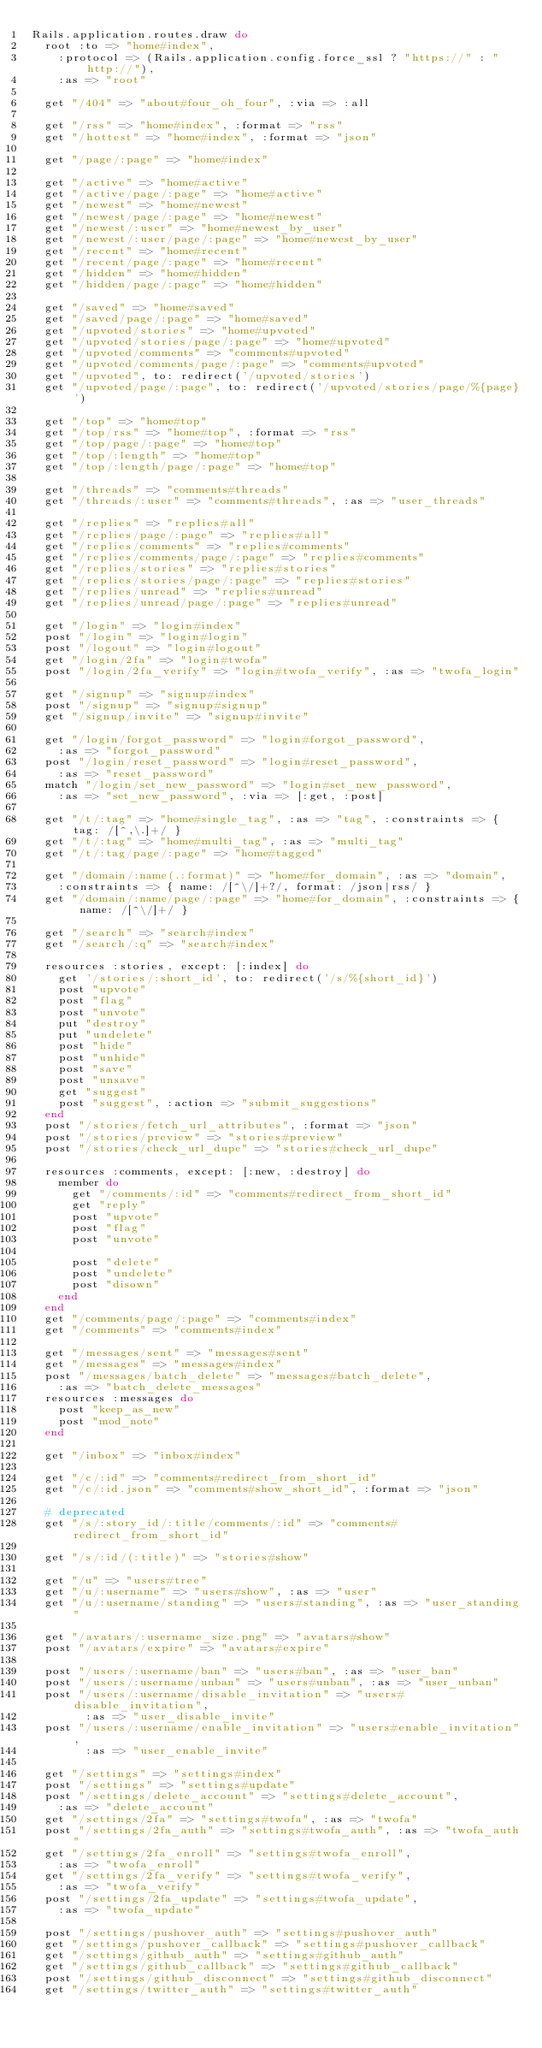<code> <loc_0><loc_0><loc_500><loc_500><_Ruby_>Rails.application.routes.draw do
  root :to => "home#index",
    :protocol => (Rails.application.config.force_ssl ? "https://" : "http://"),
    :as => "root"

  get "/404" => "about#four_oh_four", :via => :all

  get "/rss" => "home#index", :format => "rss"
  get "/hottest" => "home#index", :format => "json"

  get "/page/:page" => "home#index"

  get "/active" => "home#active"
  get "/active/page/:page" => "home#active"
  get "/newest" => "home#newest"
  get "/newest/page/:page" => "home#newest"
  get "/newest/:user" => "home#newest_by_user"
  get "/newest/:user/page/:page" => "home#newest_by_user"
  get "/recent" => "home#recent"
  get "/recent/page/:page" => "home#recent"
  get "/hidden" => "home#hidden"
  get "/hidden/page/:page" => "home#hidden"

  get "/saved" => "home#saved"
  get "/saved/page/:page" => "home#saved"
  get "/upvoted/stories" => "home#upvoted"
  get "/upvoted/stories/page/:page" => "home#upvoted"
  get "/upvoted/comments" => "comments#upvoted"
  get "/upvoted/comments/page/:page" => "comments#upvoted"
  get "/upvoted", to: redirect('/upvoted/stories')
  get "/upvoted/page/:page", to: redirect('/upvoted/stories/page/%{page}')

  get "/top" => "home#top"
  get "/top/rss" => "home#top", :format => "rss"
  get "/top/page/:page" => "home#top"
  get "/top/:length" => "home#top"
  get "/top/:length/page/:page" => "home#top"

  get "/threads" => "comments#threads"
  get "/threads/:user" => "comments#threads", :as => "user_threads"

  get "/replies" => "replies#all"
  get "/replies/page/:page" => "replies#all"
  get "/replies/comments" => "replies#comments"
  get "/replies/comments/page/:page" => "replies#comments"
  get "/replies/stories" => "replies#stories"
  get "/replies/stories/page/:page" => "replies#stories"
  get "/replies/unread" => "replies#unread"
  get "/replies/unread/page/:page" => "replies#unread"

  get "/login" => "login#index"
  post "/login" => "login#login"
  post "/logout" => "login#logout"
  get "/login/2fa" => "login#twofa"
  post "/login/2fa_verify" => "login#twofa_verify", :as => "twofa_login"

  get "/signup" => "signup#index"
  post "/signup" => "signup#signup"
  get "/signup/invite" => "signup#invite"

  get "/login/forgot_password" => "login#forgot_password",
    :as => "forgot_password"
  post "/login/reset_password" => "login#reset_password",
    :as => "reset_password"
  match "/login/set_new_password" => "login#set_new_password",
    :as => "set_new_password", :via => [:get, :post]

  get "/t/:tag" => "home#single_tag", :as => "tag", :constraints => { tag: /[^,\.]+/ }
  get "/t/:tag" => "home#multi_tag", :as => "multi_tag"
  get "/t/:tag/page/:page" => "home#tagged"

  get "/domain/:name(.:format)" => "home#for_domain", :as => "domain",
    :constraints => { name: /[^\/]+?/, format: /json|rss/ }
  get "/domain/:name/page/:page" => "home#for_domain", :constraints => { name: /[^\/]+/ }

  get "/search" => "search#index"
  get "/search/:q" => "search#index"

  resources :stories, except: [:index] do
    get '/stories/:short_id', to: redirect('/s/%{short_id}')
    post "upvote"
    post "flag"
    post "unvote"
    put "destroy"
    put "undelete"
    post "hide"
    post "unhide"
    post "save"
    post "unsave"
    get "suggest"
    post "suggest", :action => "submit_suggestions"
  end
  post "/stories/fetch_url_attributes", :format => "json"
  post "/stories/preview" => "stories#preview"
  post "/stories/check_url_dupe" => "stories#check_url_dupe"

  resources :comments, except: [:new, :destroy] do
    member do
      get "/comments/:id" => "comments#redirect_from_short_id"
      get "reply"
      post "upvote"
      post "flag"
      post "unvote"

      post "delete"
      post "undelete"
      post "disown"
    end
  end
  get "/comments/page/:page" => "comments#index"
  get "/comments" => "comments#index"

  get "/messages/sent" => "messages#sent"
  get "/messages" => "messages#index"
  post "/messages/batch_delete" => "messages#batch_delete",
    :as => "batch_delete_messages"
  resources :messages do
    post "keep_as_new"
    post "mod_note"
  end

  get "/inbox" => "inbox#index"

  get "/c/:id" => "comments#redirect_from_short_id"
  get "/c/:id.json" => "comments#show_short_id", :format => "json"

  # deprecated
  get "/s/:story_id/:title/comments/:id" => "comments#redirect_from_short_id"

  get "/s/:id/(:title)" => "stories#show"

  get "/u" => "users#tree"
  get "/u/:username" => "users#show", :as => "user"
  get "/u/:username/standing" => "users#standing", :as => "user_standing"

  get "/avatars/:username_size.png" => "avatars#show"
  post "/avatars/expire" => "avatars#expire"

  post "/users/:username/ban" => "users#ban", :as => "user_ban"
  post "/users/:username/unban" => "users#unban", :as => "user_unban"
  post "/users/:username/disable_invitation" => "users#disable_invitation",
        :as => "user_disable_invite"
  post "/users/:username/enable_invitation" => "users#enable_invitation",
        :as => "user_enable_invite"

  get "/settings" => "settings#index"
  post "/settings" => "settings#update"
  post "/settings/delete_account" => "settings#delete_account",
    :as => "delete_account"
  get "/settings/2fa" => "settings#twofa", :as => "twofa"
  post "/settings/2fa_auth" => "settings#twofa_auth", :as => "twofa_auth"
  get "/settings/2fa_enroll" => "settings#twofa_enroll",
    :as => "twofa_enroll"
  get "/settings/2fa_verify" => "settings#twofa_verify",
    :as => "twofa_verify"
  post "/settings/2fa_update" => "settings#twofa_update",
    :as => "twofa_update"

  post "/settings/pushover_auth" => "settings#pushover_auth"
  get "/settings/pushover_callback" => "settings#pushover_callback"
  get "/settings/github_auth" => "settings#github_auth"
  get "/settings/github_callback" => "settings#github_callback"
  post "/settings/github_disconnect" => "settings#github_disconnect"
  get "/settings/twitter_auth" => "settings#twitter_auth"</code> 